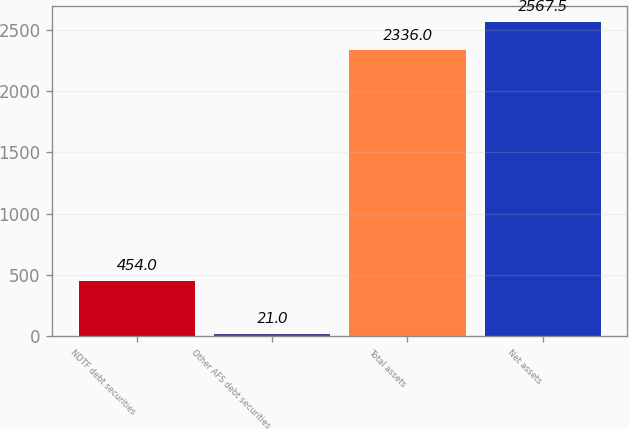<chart> <loc_0><loc_0><loc_500><loc_500><bar_chart><fcel>NDTF debt securities<fcel>Other AFS debt securities<fcel>Total assets<fcel>Net assets<nl><fcel>454<fcel>21<fcel>2336<fcel>2567.5<nl></chart> 